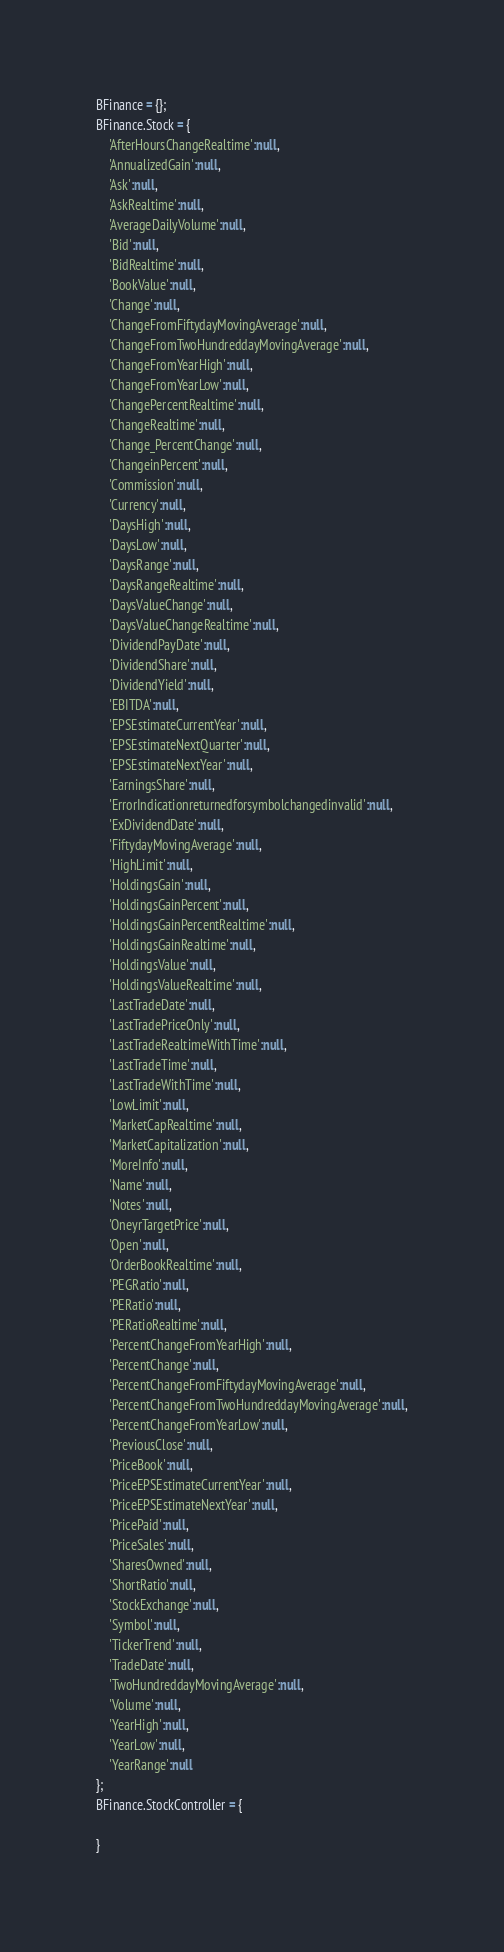<code> <loc_0><loc_0><loc_500><loc_500><_JavaScript_>BFinance = {};
BFinance.Stock = {
    'AfterHoursChangeRealtime':null,
    'AnnualizedGain':null,
    'Ask':null,
    'AskRealtime':null,
    'AverageDailyVolume':null,
    'Bid':null,
    'BidRealtime':null,
    'BookValue':null,
    'Change':null,
    'ChangeFromFiftydayMovingAverage':null,
    'ChangeFromTwoHundreddayMovingAverage':null,
    'ChangeFromYearHigh':null,
    'ChangeFromYearLow':null,
    'ChangePercentRealtime':null,
    'ChangeRealtime':null,
    'Change_PercentChange':null,
    'ChangeinPercent':null,
    'Commission':null,
    'Currency':null,
    'DaysHigh':null,
    'DaysLow':null,
    'DaysRange':null,
    'DaysRangeRealtime':null,
    'DaysValueChange':null,
    'DaysValueChangeRealtime':null,
    'DividendPayDate':null,
    'DividendShare':null,
    'DividendYield':null,
    'EBITDA':null,
    'EPSEstimateCurrentYear':null,
    'EPSEstimateNextQuarter':null,
    'EPSEstimateNextYear':null,
    'EarningsShare':null,
    'ErrorIndicationreturnedforsymbolchangedinvalid':null,
    'ExDividendDate':null,
    'FiftydayMovingAverage':null,
    'HighLimit':null,
    'HoldingsGain':null,
    'HoldingsGainPercent':null,
    'HoldingsGainPercentRealtime':null,
    'HoldingsGainRealtime':null,
    'HoldingsValue':null,
    'HoldingsValueRealtime':null,
    'LastTradeDate':null,
    'LastTradePriceOnly':null,
    'LastTradeRealtimeWithTime':null,
    'LastTradeTime':null,
    'LastTradeWithTime':null,
    'LowLimit':null,
    'MarketCapRealtime':null,
    'MarketCapitalization':null,
    'MoreInfo':null,
    'Name':null,
    'Notes':null,
    'OneyrTargetPrice':null,
    'Open':null,
    'OrderBookRealtime':null,
    'PEGRatio':null,
    'PERatio':null,
    'PERatioRealtime':null,
    'PercentChangeFromYearHigh':null,
    'PercentChange':null,
    'PercentChangeFromFiftydayMovingAverage':null,
    'PercentChangeFromTwoHundreddayMovingAverage':null,
    'PercentChangeFromYearLow':null,
    'PreviousClose':null,
    'PriceBook':null,
    'PriceEPSEstimateCurrentYear':null,
    'PriceEPSEstimateNextYear':null,
    'PricePaid':null,
    'PriceSales':null,
    'SharesOwned':null,
    'ShortRatio':null,
    'StockExchange':null,
    'Symbol':null,
    'TickerTrend':null,
    'TradeDate':null,
    'TwoHundreddayMovingAverage':null,
    'Volume':null,
    'YearHigh':null,
    'YearLow':null,
    'YearRange':null
};
BFinance.StockController = {

}</code> 